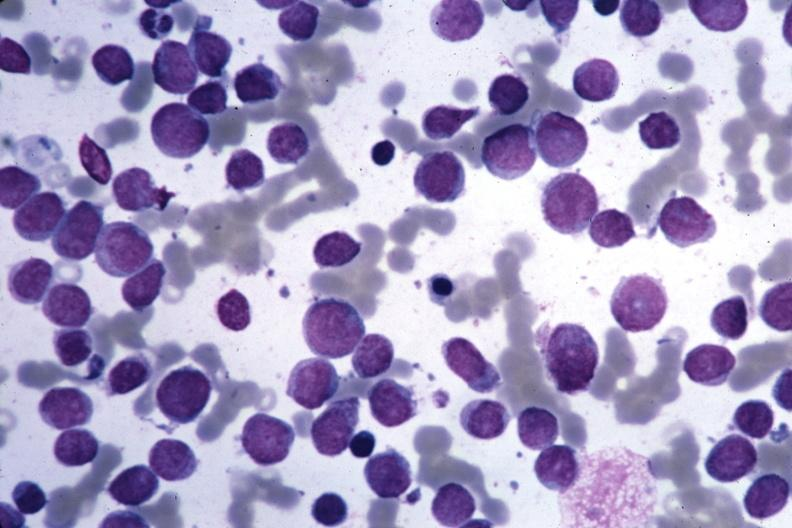s cervical leiomyoma present?
Answer the question using a single word or phrase. No 